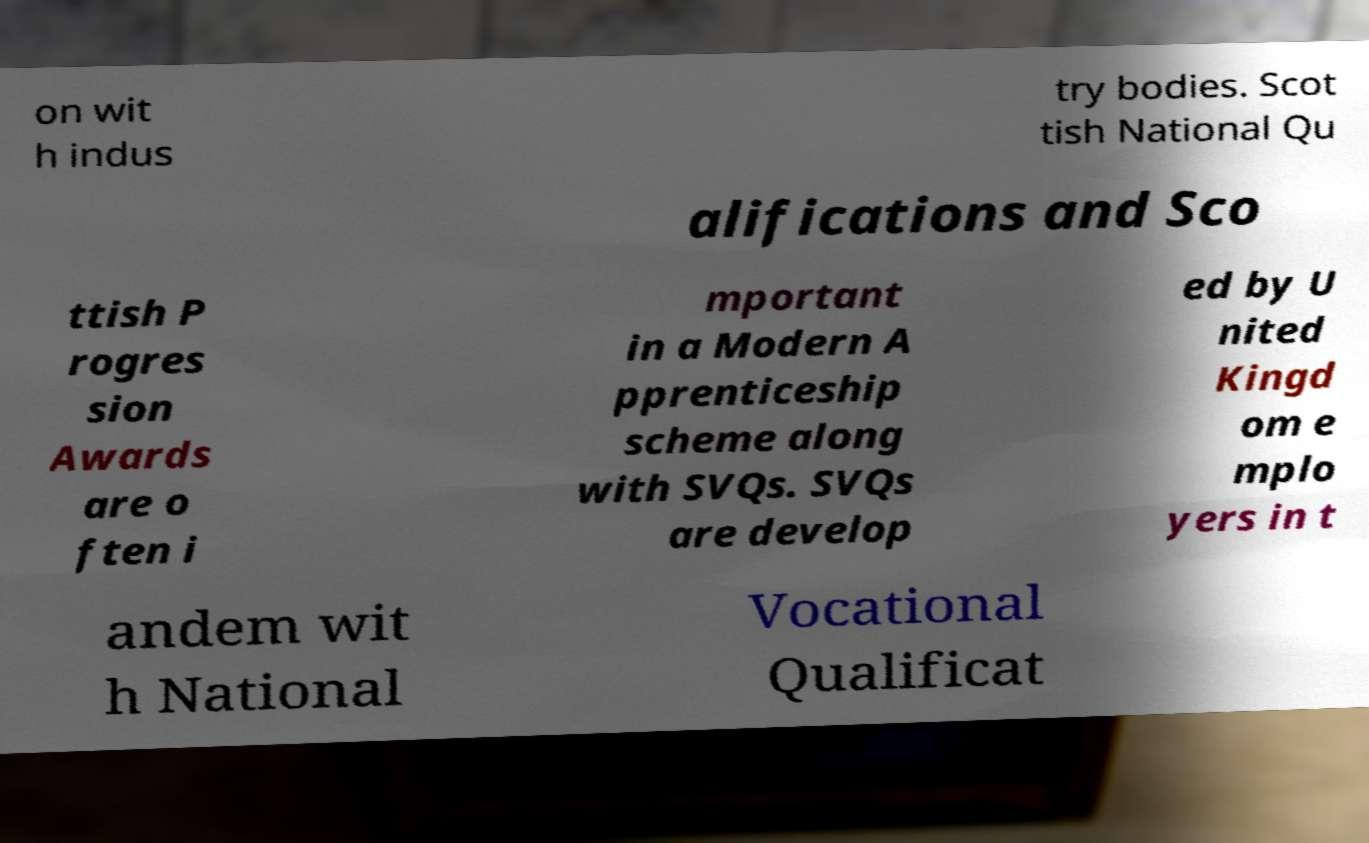Can you accurately transcribe the text from the provided image for me? on wit h indus try bodies. Scot tish National Qu alifications and Sco ttish P rogres sion Awards are o ften i mportant in a Modern A pprenticeship scheme along with SVQs. SVQs are develop ed by U nited Kingd om e mplo yers in t andem wit h National Vocational Qualificat 